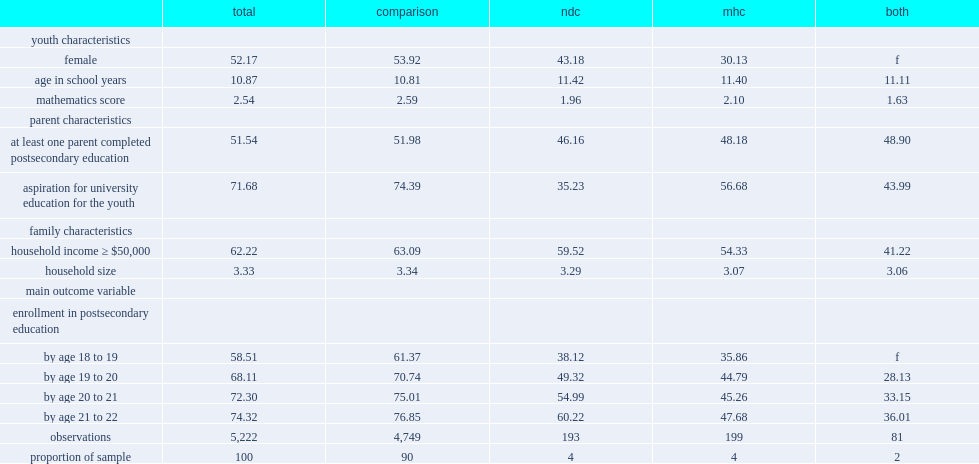What was the percentage of youth in the comparison group enrolled in pse by age 21 to 22? 76.85. What was the percentage of youth diagnosed with an ndc enrolled in pse by age 21 to 22? 60.22. What was the percentage of youth diagnosed with both an ndc and an mhc enrolled in pse by age 21 to 22? 36.01. 